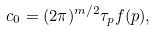<formula> <loc_0><loc_0><loc_500><loc_500>c _ { 0 } = ( 2 \pi ) ^ { m / 2 } \tau _ { p } f ( p ) ,</formula> 